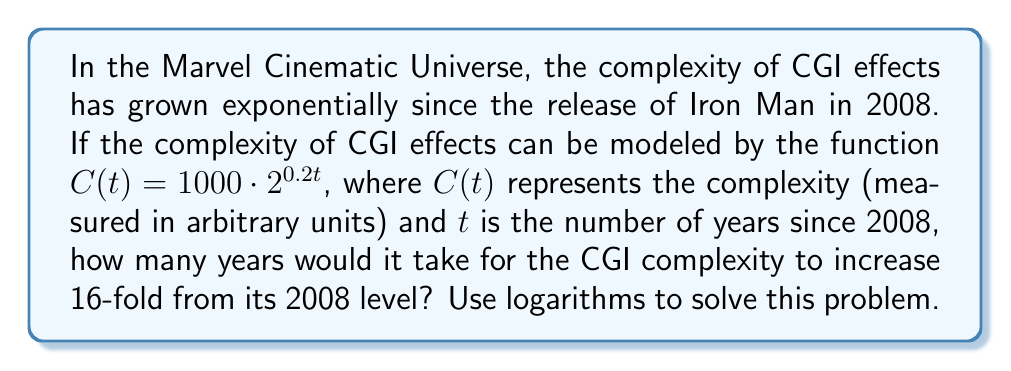What is the answer to this math problem? Let's approach this step-by-step:

1) We want to find $t$ when $C(t) = 16 \cdot C(0)$

2) First, let's calculate $C(0)$:
   $C(0) = 1000 \cdot 2^{0.2 \cdot 0} = 1000$

3) Now, we can set up our equation:
   $1000 \cdot 2^{0.2t} = 16 \cdot 1000$

4) Simplify the right side:
   $1000 \cdot 2^{0.2t} = 16000$

5) Divide both sides by 1000:
   $2^{0.2t} = 16$

6) Now, we can apply logarithms to both sides. Let's use log base 2:
   $\log_2(2^{0.2t}) = \log_2(16)$

7) Using the logarithm property $\log_a(a^x) = x$:
   $0.2t \cdot \log_2(2) = \log_2(16)$

8) Simplify, knowing that $\log_2(2) = 1$:
   $0.2t = \log_2(16)$

9) We know that $\log_2(16) = 4$ because $2^4 = 16$:
   $0.2t = 4$

10) Solve for $t$:
    $t = 4 / 0.2 = 20$

Therefore, it would take 20 years for the CGI complexity to increase 16-fold from its 2008 level.
Answer: 20 years 